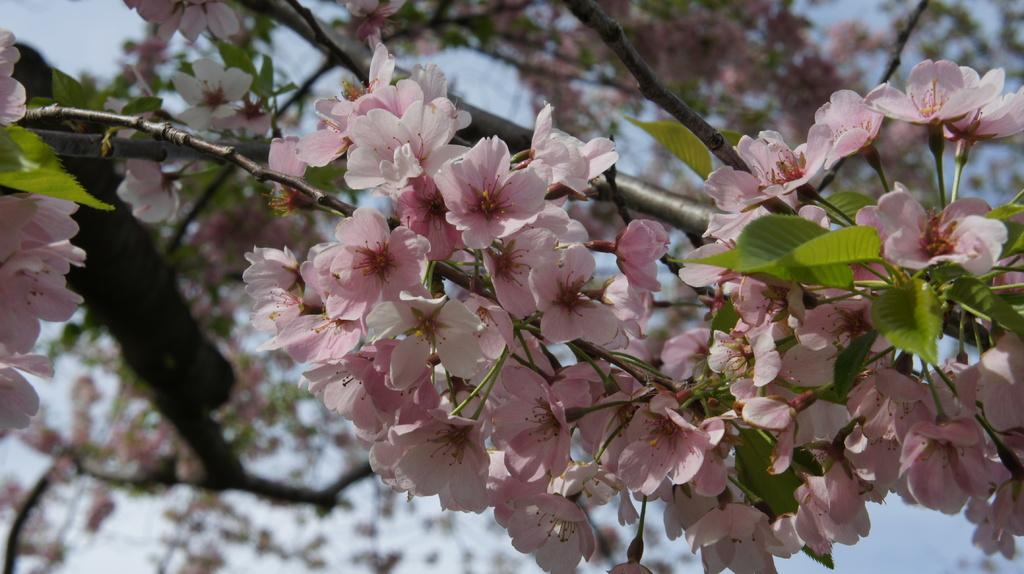What is the main subject of the image? The main subject of the image is a group of flowers. Where are the flowers located in relation to other objects in the image? The flowers are near a tree. What type of ring can be seen on the tree in the image? There is no ring present on the tree in the image; it only features a group of flowers near the tree. 